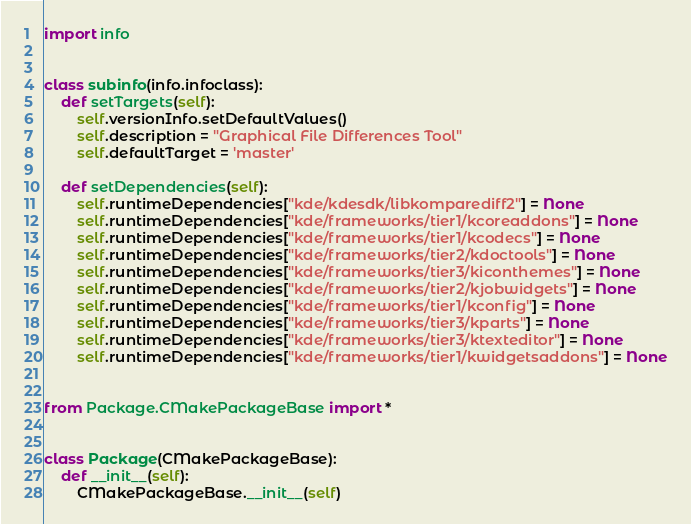Convert code to text. <code><loc_0><loc_0><loc_500><loc_500><_Python_>import info


class subinfo(info.infoclass):
    def setTargets(self):
        self.versionInfo.setDefaultValues()
        self.description = "Graphical File Differences Tool"
        self.defaultTarget = 'master'

    def setDependencies(self):
        self.runtimeDependencies["kde/kdesdk/libkomparediff2"] = None
        self.runtimeDependencies["kde/frameworks/tier1/kcoreaddons"] = None
        self.runtimeDependencies["kde/frameworks/tier1/kcodecs"] = None
        self.runtimeDependencies["kde/frameworks/tier2/kdoctools"] = None
        self.runtimeDependencies["kde/frameworks/tier3/kiconthemes"] = None
        self.runtimeDependencies["kde/frameworks/tier2/kjobwidgets"] = None
        self.runtimeDependencies["kde/frameworks/tier1/kconfig"] = None
        self.runtimeDependencies["kde/frameworks/tier3/kparts"] = None
        self.runtimeDependencies["kde/frameworks/tier3/ktexteditor"] = None
        self.runtimeDependencies["kde/frameworks/tier1/kwidgetsaddons"] = None


from Package.CMakePackageBase import *


class Package(CMakePackageBase):
    def __init__(self):
        CMakePackageBase.__init__(self)
</code> 